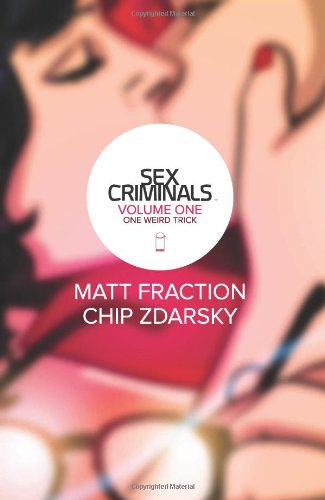Who is the author of this book? The book 'Sex Criminals' is co-authored by Matt Fraction and Chip Zdarsky. Both are renowned for their work in the comics industry. 